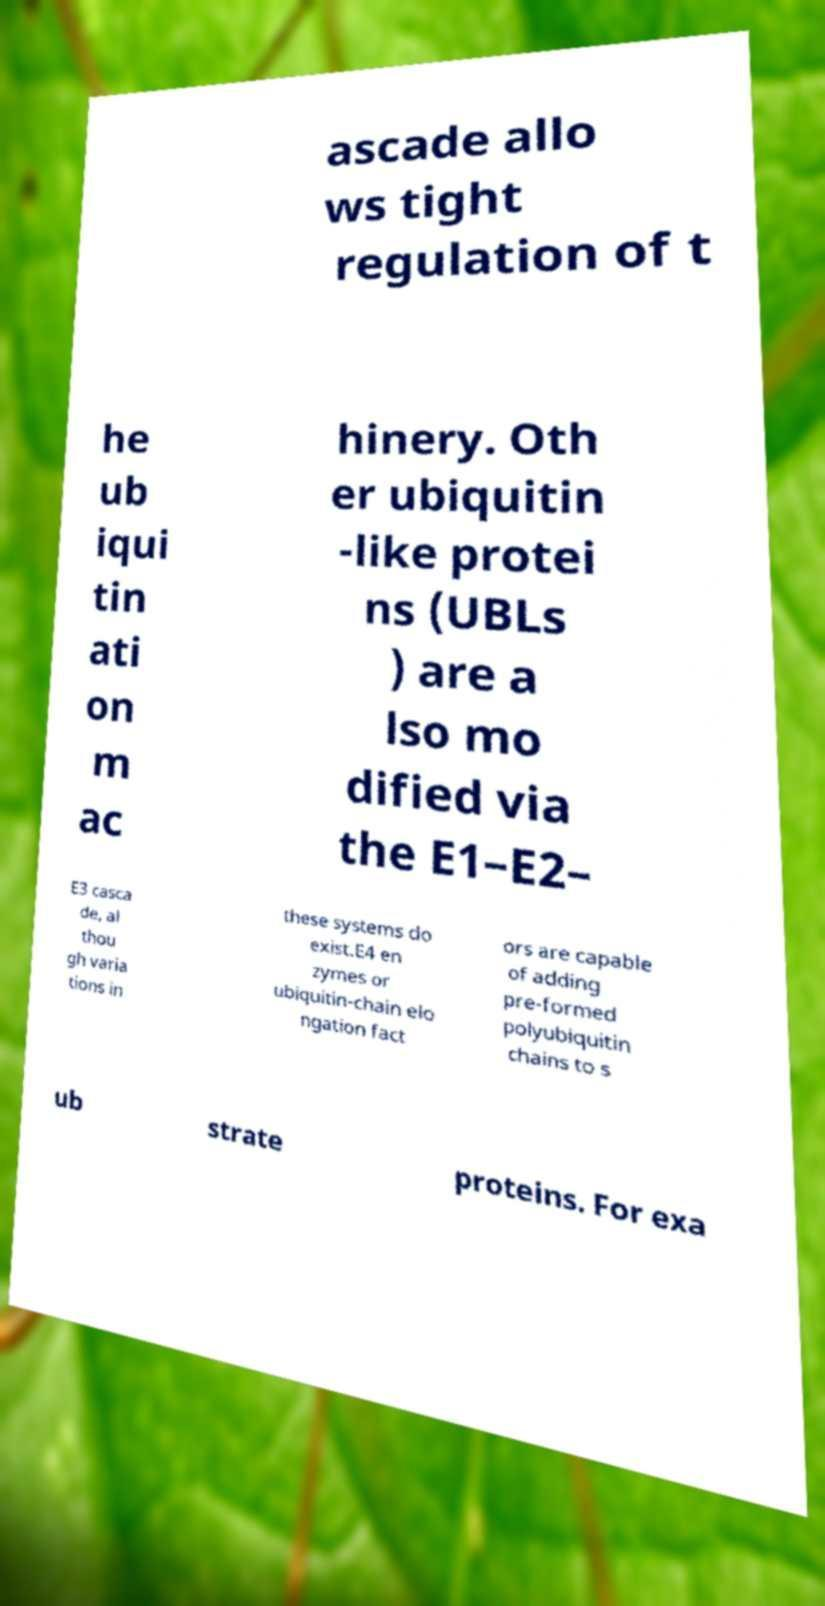Please identify and transcribe the text found in this image. ascade allo ws tight regulation of t he ub iqui tin ati on m ac hinery. Oth er ubiquitin -like protei ns (UBLs ) are a lso mo dified via the E1–E2– E3 casca de, al thou gh varia tions in these systems do exist.E4 en zymes or ubiquitin-chain elo ngation fact ors are capable of adding pre-formed polyubiquitin chains to s ub strate proteins. For exa 